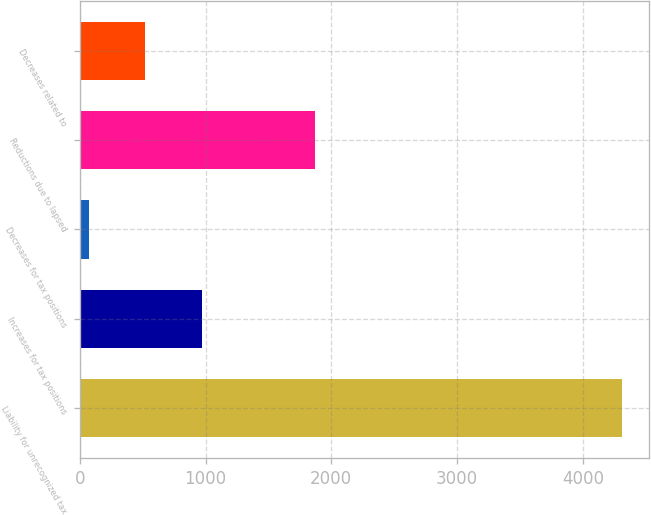<chart> <loc_0><loc_0><loc_500><loc_500><bar_chart><fcel>Liability for unrecognized tax<fcel>Increases for tax positions<fcel>Decreases for tax positions<fcel>Reductions due to lapsed<fcel>Decreases related to<nl><fcel>4308<fcel>969<fcel>70<fcel>1868<fcel>519.5<nl></chart> 